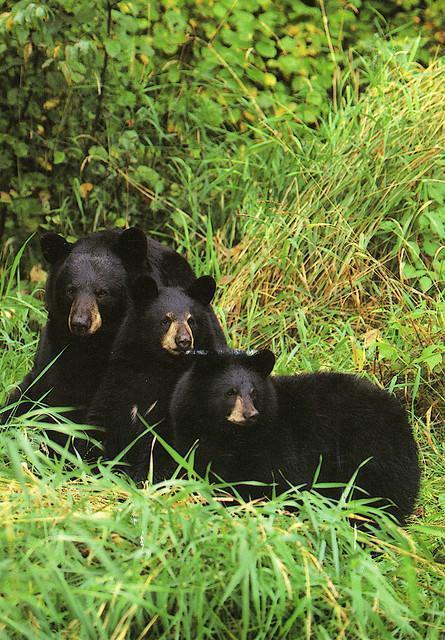What kind of diet do they adhere to?
Indicate the correct choice and explain in the format: 'Answer: answer
Rationale: rationale.'
Options: Carnivore, omnivore, monophagous, herbivore. Answer: omnivore.
Rationale: These bears adhere to an omnivorous diet. 